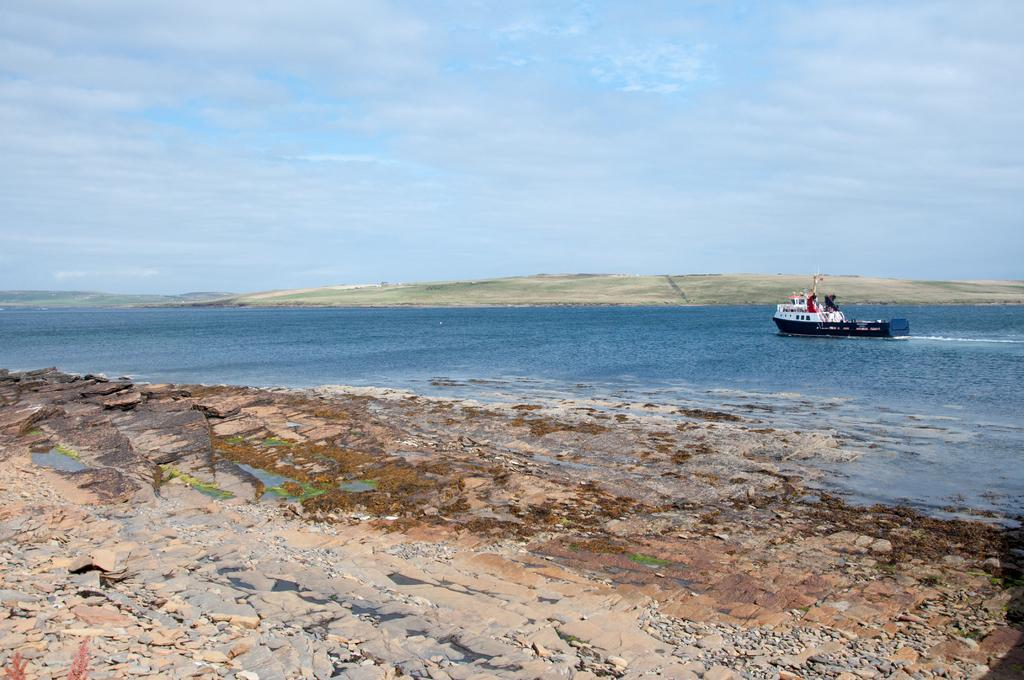Where was the image taken? The image was taken at the seashore. What is the main subject in the center of the image? There is a boat in the center of the image. Is the boat on the water or land? The boat is on the river. What can be seen in the background of the image? There is a sky visible in the background of the image. How many kittens are playing with the boat in the image? There are no kittens present in the image. What type of property is visible near the boat in the image? There is no property visible in the image; it only features the boat and the river. 